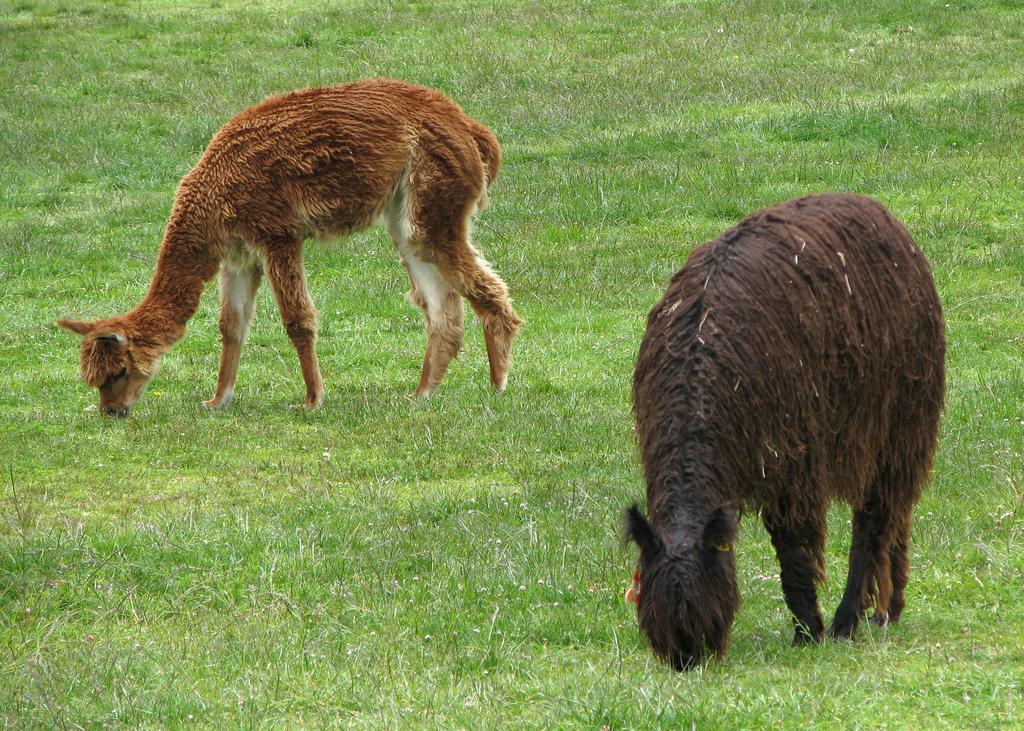Could you give a brief overview of what you see in this image? In this image I can see two animals in brown, cream and black color. I can see the green color grass. 